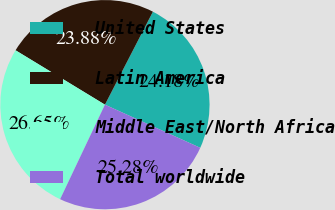Convert chart. <chart><loc_0><loc_0><loc_500><loc_500><pie_chart><fcel>United States<fcel>Latin America<fcel>Middle East/North Africa<fcel>Total worldwide<nl><fcel>24.18%<fcel>23.88%<fcel>26.65%<fcel>25.28%<nl></chart> 